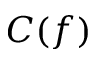<formula> <loc_0><loc_0><loc_500><loc_500>C ( f )</formula> 